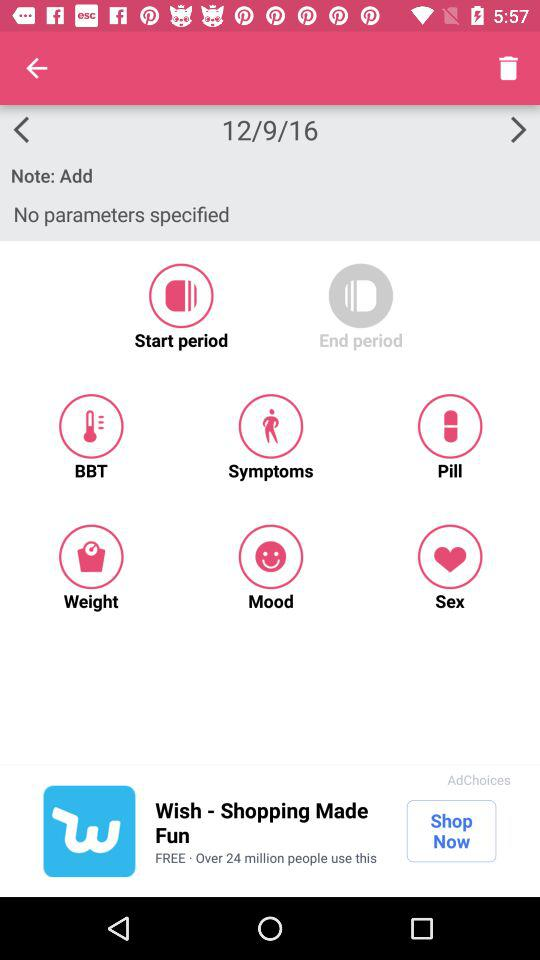What is the date? The date is December 9, 2016. 